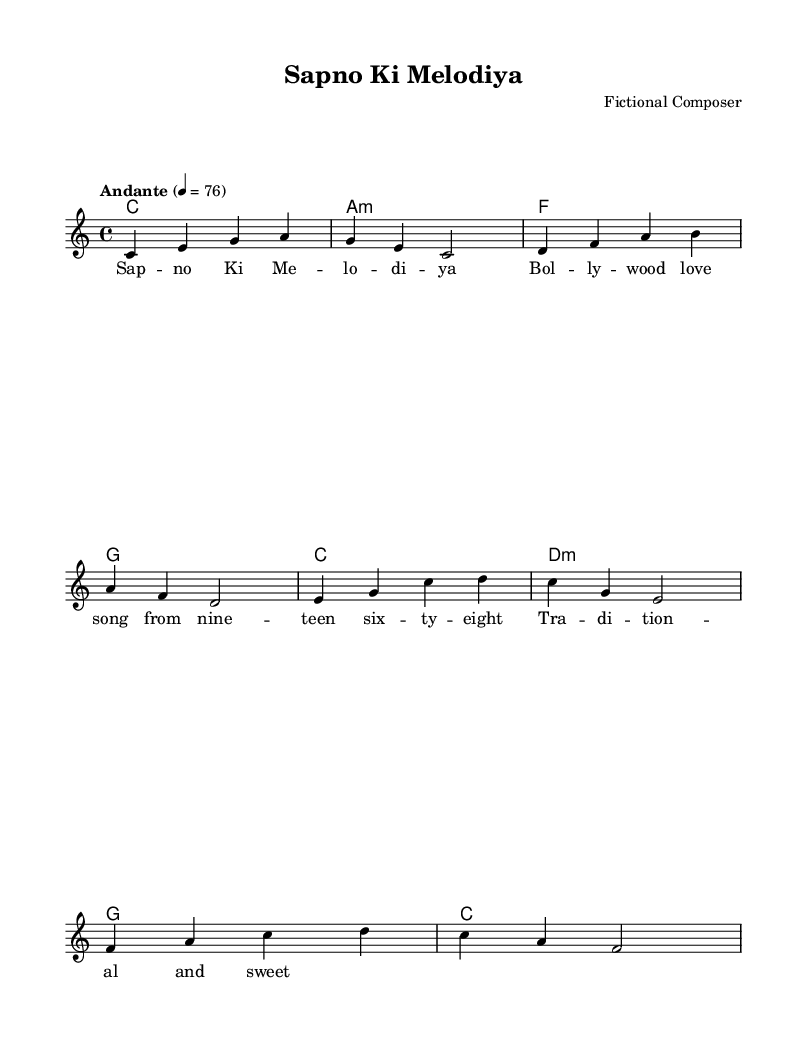What is the key signature of this music? The key signature is indicated at the beginning of the score. "C major" means there are no sharps or flats in the key signature.
Answer: C major What is the time signature of the piece? The time signature is found at the beginning of the score and is notated as "4/4". This means there are four beats in each measure and the quarter note gets one beat.
Answer: 4/4 What is the tempo marking of the piece? The tempo marking is indicated with the word "Andante" along with a metronome marking of "4 = 76." This describes the speed at which the piece should be played.
Answer: Andante What is the main melody composed in which octave? The melody is written in the relative octave, which is indicated by the use of a lower case "c" at the start. The melody starts from the note "c" in the fourth octave.
Answer: Fourth octave How many measures are there in the melody? To determine the number of measures, count the number of vertical bar lines separating the notation in the melody section. Each measure is separated by a bar line. In this case, there are four measures.
Answer: Four What is the structure of the harmony in this piece? The harmony section uses chords defined by "chordmode" notation. By analyzing the chord progression, it starts with the tonic (C major), followed by minor and major chords, suggesting a typical romantic structure.
Answer: Tonic, minor, major What year is associated with the song indicated in the lyrics? The lyrics mention "nine – teen six – ty – eight," which corresponds to the year 1968. This gives context to the era of the song, making it a recognizable Bollywood love song from that time.
Answer: 1968 